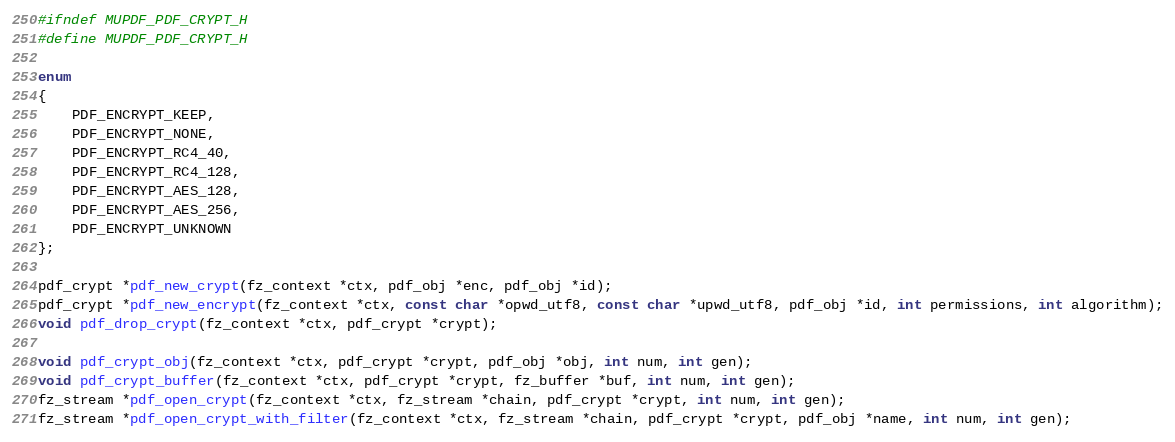<code> <loc_0><loc_0><loc_500><loc_500><_C_>#ifndef MUPDF_PDF_CRYPT_H
#define MUPDF_PDF_CRYPT_H

enum
{
	PDF_ENCRYPT_KEEP,
	PDF_ENCRYPT_NONE,
	PDF_ENCRYPT_RC4_40,
	PDF_ENCRYPT_RC4_128,
	PDF_ENCRYPT_AES_128,
	PDF_ENCRYPT_AES_256,
	PDF_ENCRYPT_UNKNOWN
};

pdf_crypt *pdf_new_crypt(fz_context *ctx, pdf_obj *enc, pdf_obj *id);
pdf_crypt *pdf_new_encrypt(fz_context *ctx, const char *opwd_utf8, const char *upwd_utf8, pdf_obj *id, int permissions, int algorithm);
void pdf_drop_crypt(fz_context *ctx, pdf_crypt *crypt);

void pdf_crypt_obj(fz_context *ctx, pdf_crypt *crypt, pdf_obj *obj, int num, int gen);
void pdf_crypt_buffer(fz_context *ctx, pdf_crypt *crypt, fz_buffer *buf, int num, int gen);
fz_stream *pdf_open_crypt(fz_context *ctx, fz_stream *chain, pdf_crypt *crypt, int num, int gen);
fz_stream *pdf_open_crypt_with_filter(fz_context *ctx, fz_stream *chain, pdf_crypt *crypt, pdf_obj *name, int num, int gen);
</code> 